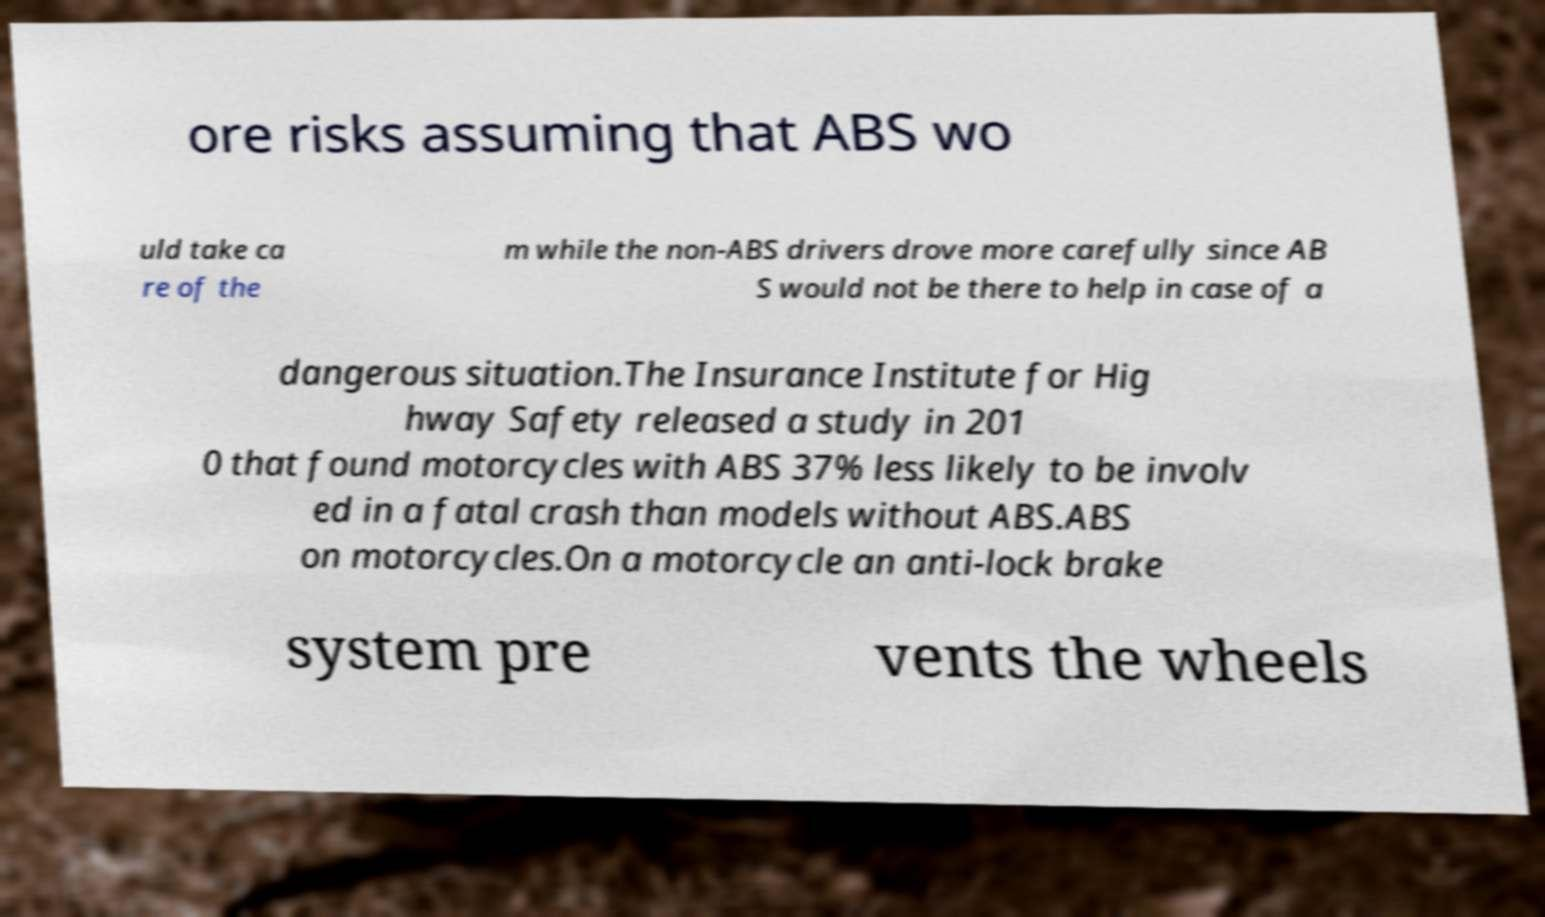Please identify and transcribe the text found in this image. ore risks assuming that ABS wo uld take ca re of the m while the non-ABS drivers drove more carefully since AB S would not be there to help in case of a dangerous situation.The Insurance Institute for Hig hway Safety released a study in 201 0 that found motorcycles with ABS 37% less likely to be involv ed in a fatal crash than models without ABS.ABS on motorcycles.On a motorcycle an anti-lock brake system pre vents the wheels 